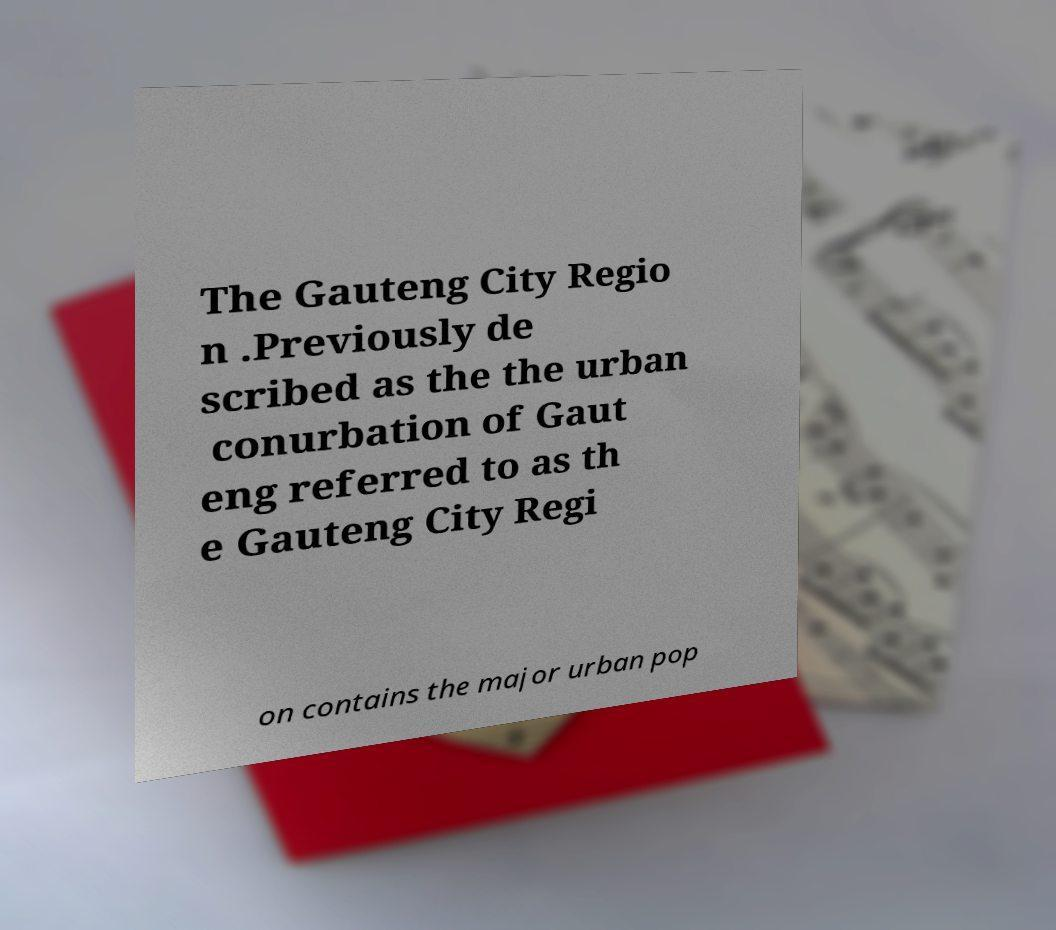Could you assist in decoding the text presented in this image and type it out clearly? The Gauteng City Regio n .Previously de scribed as the the urban conurbation of Gaut eng referred to as th e Gauteng City Regi on contains the major urban pop 